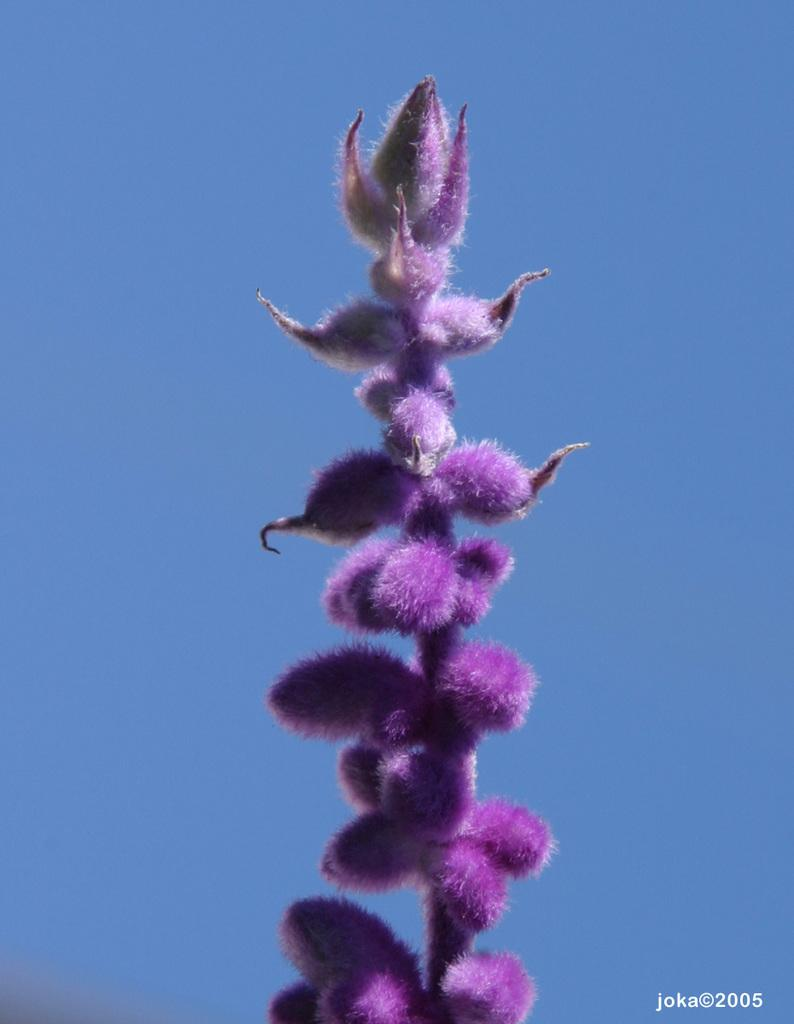What type of flower is present in the image? There is a violet color flower in the image. Is there any text or writing in the image? Yes, there is text or writing in the right bottom corner of the image. What color is the sky in the image? The sky is blue in color. How many tomatoes are being harvested by the farmer in the image? There are no tomatoes or farmers present in the image. 